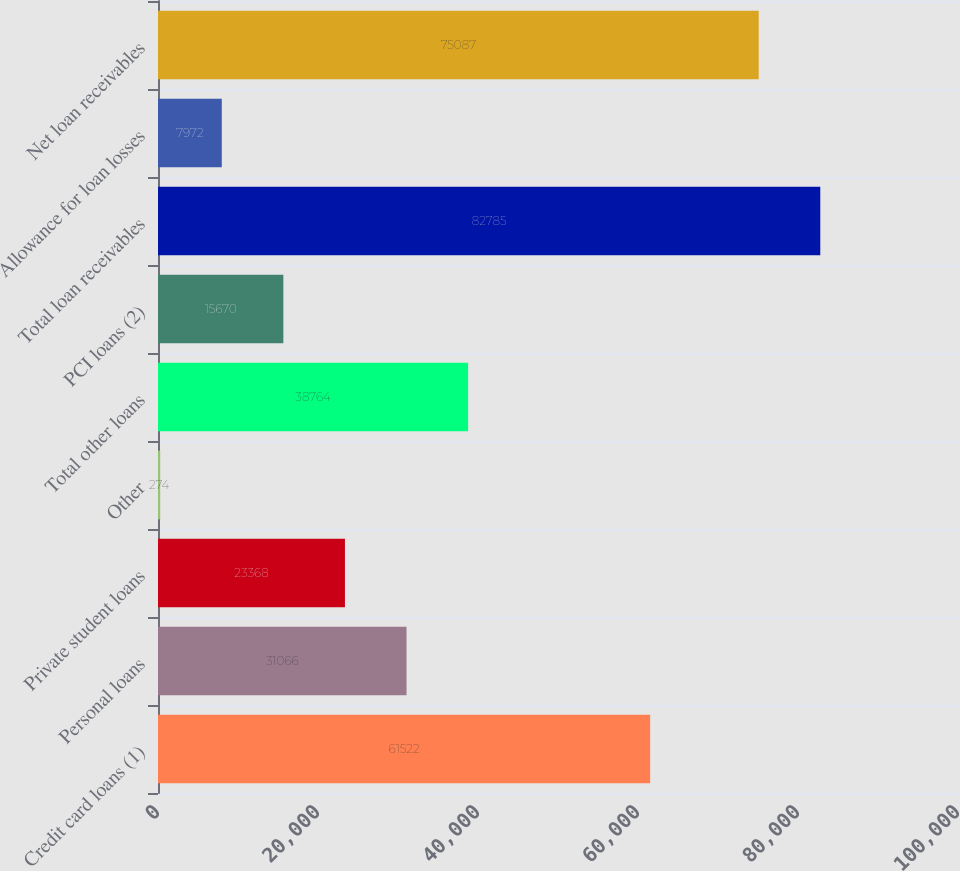Convert chart. <chart><loc_0><loc_0><loc_500><loc_500><bar_chart><fcel>Credit card loans (1)<fcel>Personal loans<fcel>Private student loans<fcel>Other<fcel>Total other loans<fcel>PCI loans (2)<fcel>Total loan receivables<fcel>Allowance for loan losses<fcel>Net loan receivables<nl><fcel>61522<fcel>31066<fcel>23368<fcel>274<fcel>38764<fcel>15670<fcel>82785<fcel>7972<fcel>75087<nl></chart> 